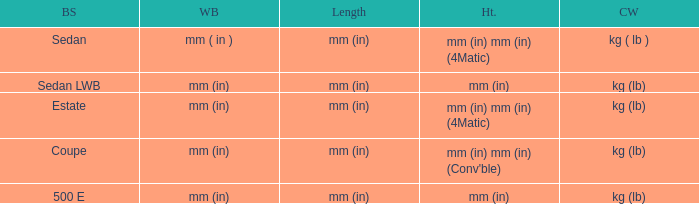What's the length of the model with 500 E body style? Mm (in). 